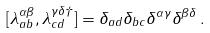Convert formula to latex. <formula><loc_0><loc_0><loc_500><loc_500>[ \lambda ^ { \alpha \beta } _ { a b } , \lambda ^ { \gamma \delta \dagger } _ { c d } ] = \delta _ { a d } \delta _ { b c } \delta ^ { \alpha \gamma } \delta ^ { \beta \delta } \, .</formula> 